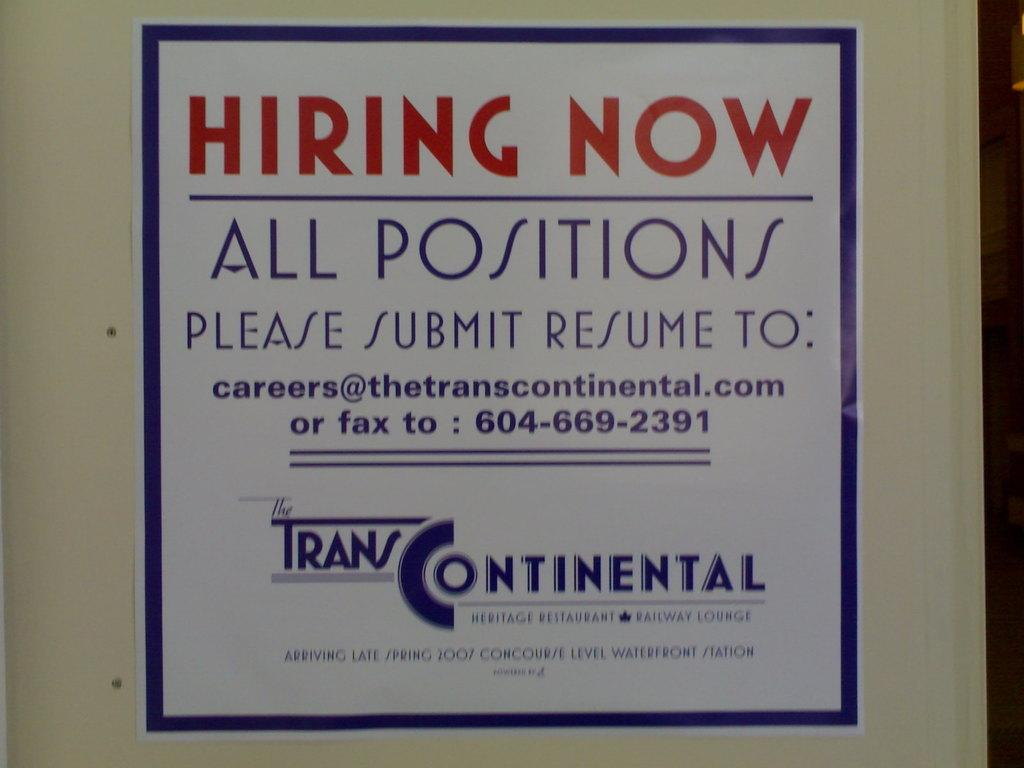<image>
Offer a succinct explanation of the picture presented. A poster advertising open job positions for Trans Continental. 